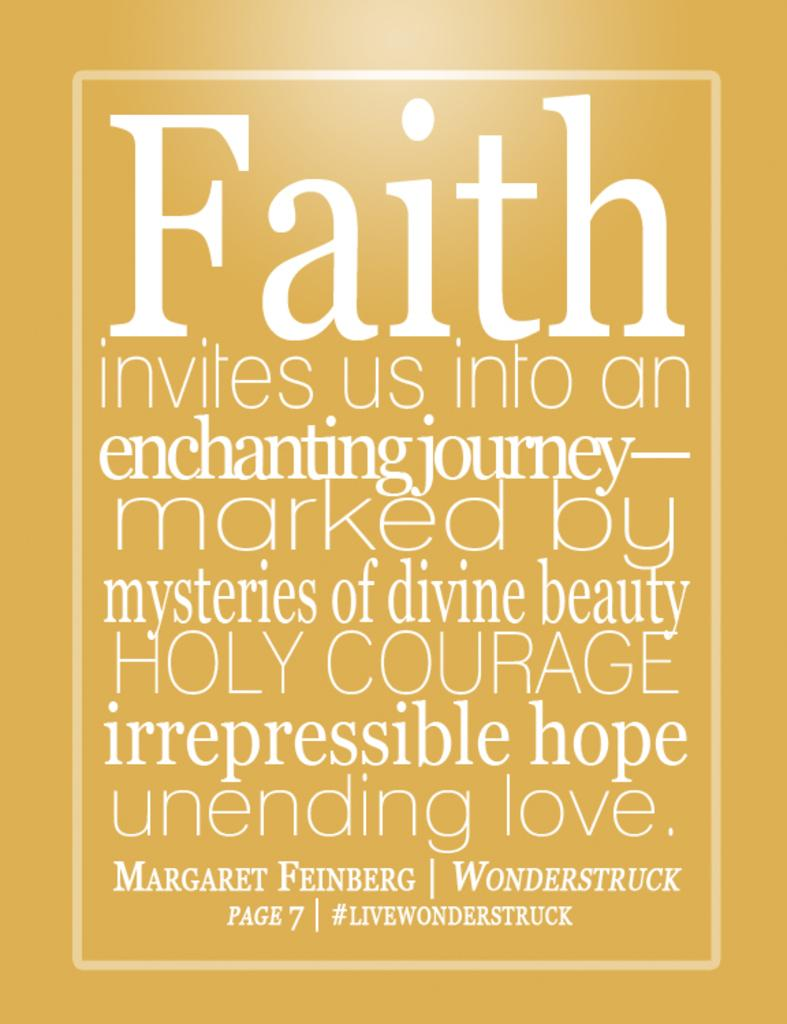<image>
Render a clear and concise summary of the photo. A yellowish colored poster with the largest word being faith. 